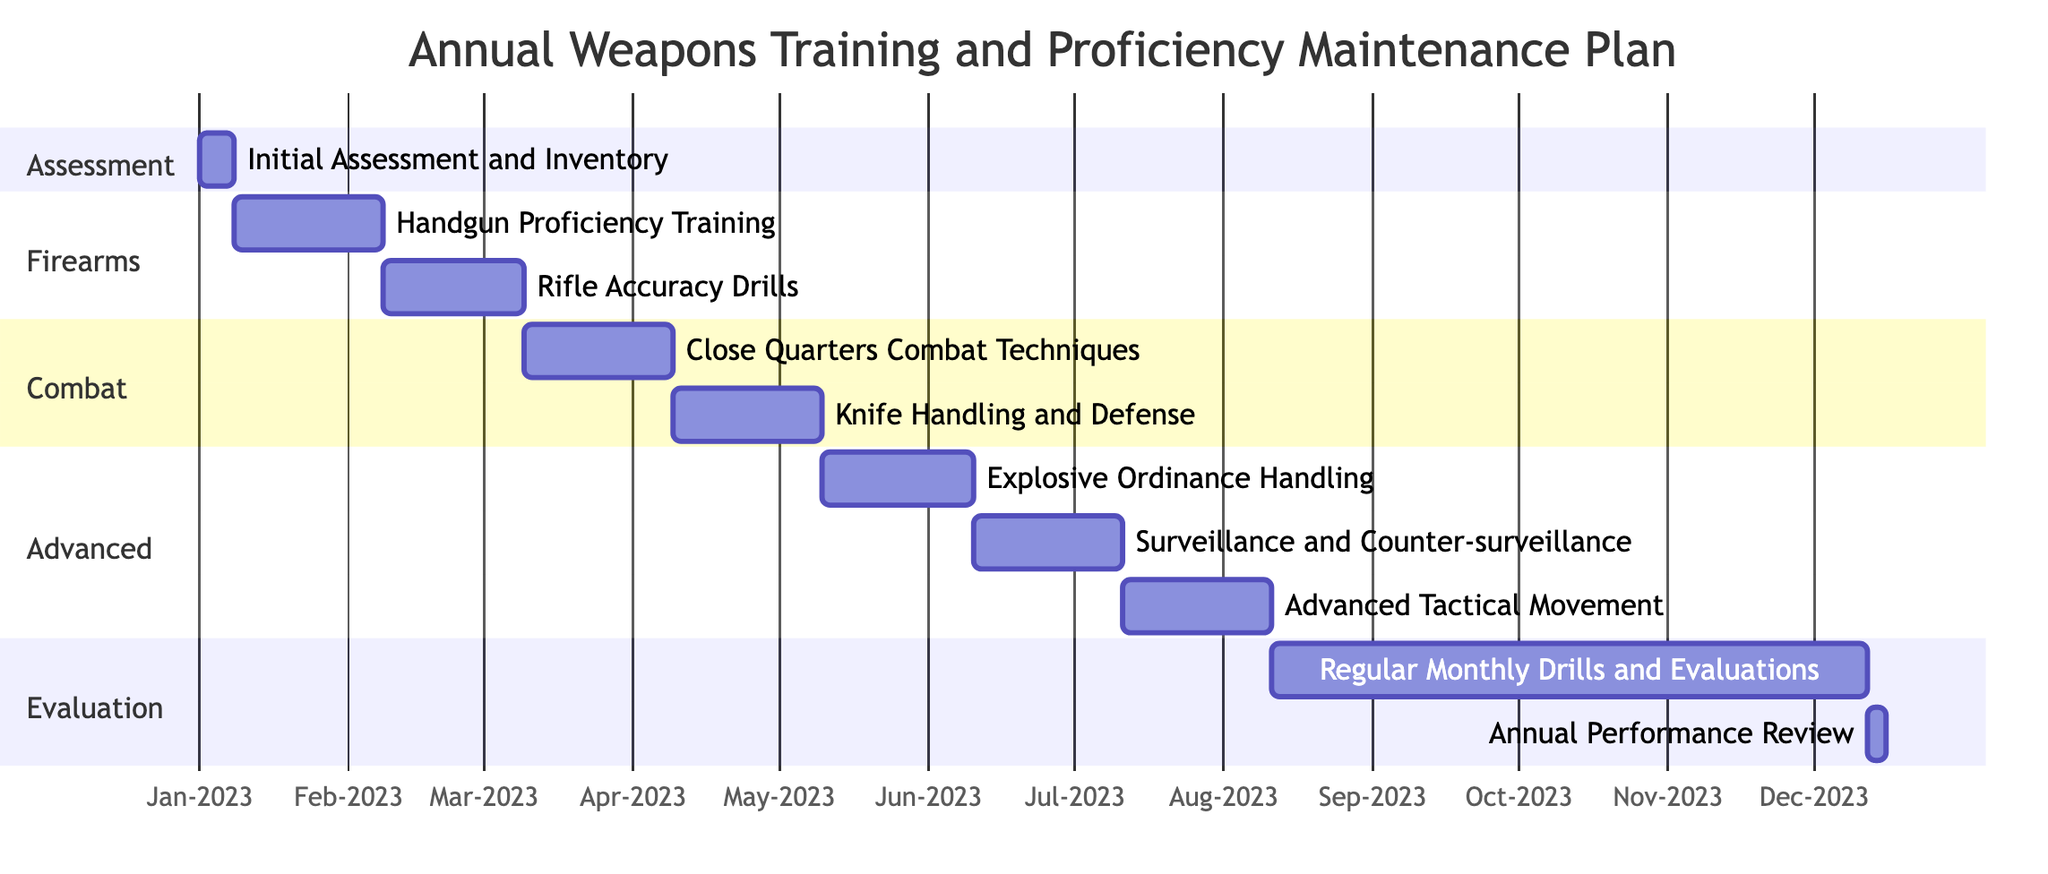What is the duration of Handgun Proficiency Training? The Handgun Proficiency Training starts on January 8, 2023, and ends on February 7, 2023. This is a span of 31 days.
Answer: 31 days What task follows Close Quarters Combat Techniques? The Close Quarters Combat Techniques task is followed by the Knife Handling and Defense task, as indicated by the dependency.
Answer: Knife Handling and Defense How many tasks are listed in the diagram? The diagram lists ten tasks in total, as counted from the task list provided.
Answer: Ten tasks What is the start date of the Annual Performance Review? The Annual Performance Review starts on December 28, 2023, according to the schedule established in the diagram.
Answer: December 28, 2023 Which section does Explosive Ordinance Handling belong to? The Explosive Ordinance Handling task is part of the Advanced section, as noted in the Gantt chart structure.
Answer: Advanced When does the Regular Monthly Drills and Evaluations end? It ends on December 25, 2023, which is the last date indicated for that task in the diagram.
Answer: December 25, 2023 What is the total duration of the Evaluation section? There are two tasks in the Evaluation section: Regular Monthly Drills and Evaluations (123 days) and Annual Performance Review (4 days), resulting in a total of 127 days when summed.
Answer: 127 days What task must be completed before starting Advanced Tactical Movement? Advanced Tactical Movement depends on the completion of Surveillance and Counter-surveillance Techniques, which must be finished beforehand.
Answer: Surveillance and Counter-surveillance Techniques How long after Initial Assessment and Inventory does Knife Handling and Defense start? Knife Handling and Defense starts on April 15, 2023, which is 108 days after the completion of Initial Assessment and Inventory.
Answer: 108 days 